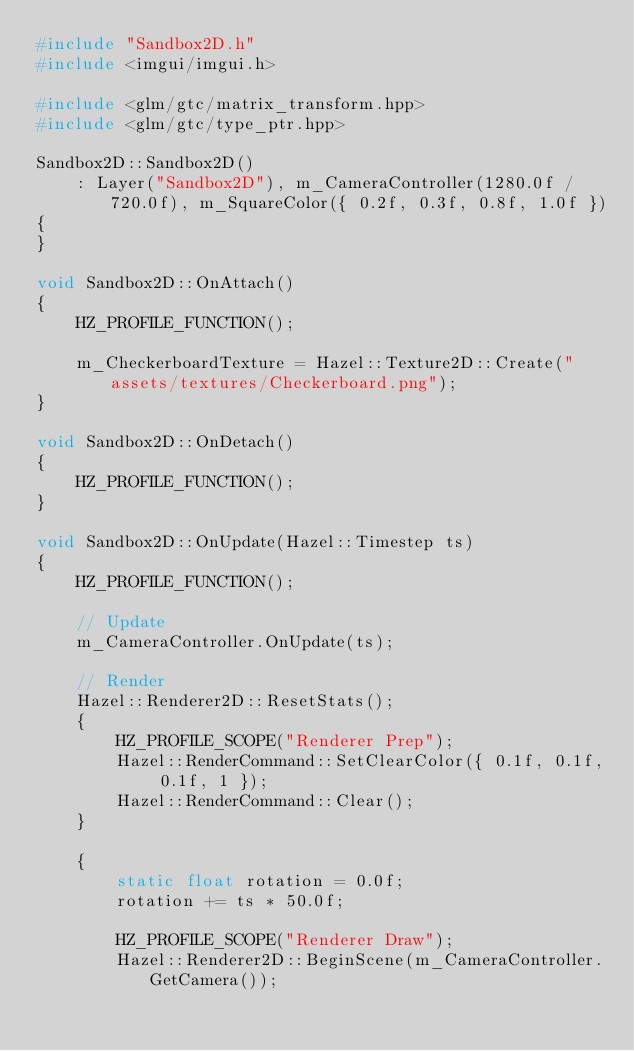<code> <loc_0><loc_0><loc_500><loc_500><_C++_>#include "Sandbox2D.h"
#include <imgui/imgui.h>

#include <glm/gtc/matrix_transform.hpp>
#include <glm/gtc/type_ptr.hpp>

Sandbox2D::Sandbox2D()
	: Layer("Sandbox2D"), m_CameraController(1280.0f / 720.0f), m_SquareColor({ 0.2f, 0.3f, 0.8f, 1.0f })
{
}

void Sandbox2D::OnAttach()
{
	HZ_PROFILE_FUNCTION();

	m_CheckerboardTexture = Hazel::Texture2D::Create("assets/textures/Checkerboard.png");
}

void Sandbox2D::OnDetach()
{
	HZ_PROFILE_FUNCTION();
}

void Sandbox2D::OnUpdate(Hazel::Timestep ts)
{
	HZ_PROFILE_FUNCTION();

	// Update
	m_CameraController.OnUpdate(ts);

	// Render
	Hazel::Renderer2D::ResetStats();
	{
		HZ_PROFILE_SCOPE("Renderer Prep");
		Hazel::RenderCommand::SetClearColor({ 0.1f, 0.1f, 0.1f, 1 });
		Hazel::RenderCommand::Clear();
	}

	{
		static float rotation = 0.0f;
		rotation += ts * 50.0f;

		HZ_PROFILE_SCOPE("Renderer Draw");
		Hazel::Renderer2D::BeginScene(m_CameraController.GetCamera());</code> 